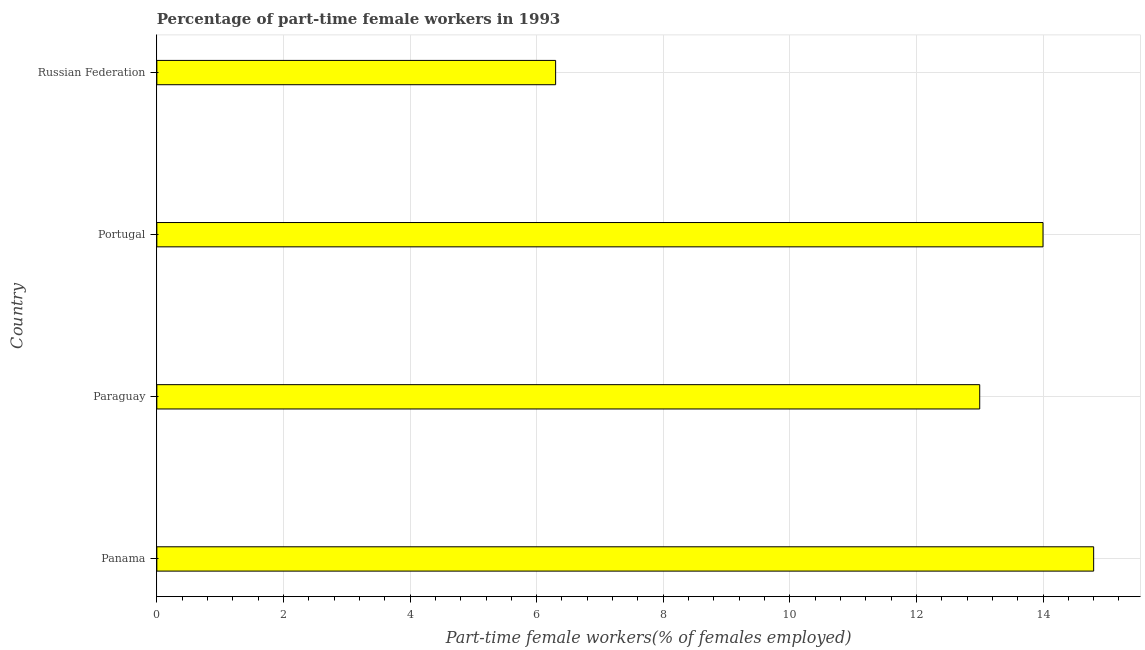Does the graph contain any zero values?
Your response must be concise. No. What is the title of the graph?
Offer a terse response. Percentage of part-time female workers in 1993. What is the label or title of the X-axis?
Offer a terse response. Part-time female workers(% of females employed). What is the label or title of the Y-axis?
Your answer should be compact. Country. Across all countries, what is the maximum percentage of part-time female workers?
Your answer should be compact. 14.8. Across all countries, what is the minimum percentage of part-time female workers?
Your answer should be very brief. 6.3. In which country was the percentage of part-time female workers maximum?
Offer a terse response. Panama. In which country was the percentage of part-time female workers minimum?
Make the answer very short. Russian Federation. What is the sum of the percentage of part-time female workers?
Ensure brevity in your answer.  48.1. What is the average percentage of part-time female workers per country?
Ensure brevity in your answer.  12.03. What is the median percentage of part-time female workers?
Ensure brevity in your answer.  13.5. In how many countries, is the percentage of part-time female workers greater than 7.6 %?
Provide a short and direct response. 3. What is the ratio of the percentage of part-time female workers in Paraguay to that in Russian Federation?
Your answer should be compact. 2.06. Is the difference between the percentage of part-time female workers in Paraguay and Russian Federation greater than the difference between any two countries?
Provide a short and direct response. No. What is the difference between the highest and the second highest percentage of part-time female workers?
Make the answer very short. 0.8. Is the sum of the percentage of part-time female workers in Panama and Portugal greater than the maximum percentage of part-time female workers across all countries?
Keep it short and to the point. Yes. What is the difference between the highest and the lowest percentage of part-time female workers?
Your response must be concise. 8.5. In how many countries, is the percentage of part-time female workers greater than the average percentage of part-time female workers taken over all countries?
Give a very brief answer. 3. How many bars are there?
Offer a very short reply. 4. Are the values on the major ticks of X-axis written in scientific E-notation?
Make the answer very short. No. What is the Part-time female workers(% of females employed) in Panama?
Your answer should be very brief. 14.8. What is the Part-time female workers(% of females employed) of Paraguay?
Keep it short and to the point. 13. What is the Part-time female workers(% of females employed) of Portugal?
Your answer should be very brief. 14. What is the Part-time female workers(% of females employed) of Russian Federation?
Make the answer very short. 6.3. What is the difference between the Part-time female workers(% of females employed) in Panama and Paraguay?
Make the answer very short. 1.8. What is the difference between the Part-time female workers(% of females employed) in Panama and Portugal?
Give a very brief answer. 0.8. What is the difference between the Part-time female workers(% of females employed) in Panama and Russian Federation?
Provide a short and direct response. 8.5. What is the difference between the Part-time female workers(% of females employed) in Paraguay and Portugal?
Make the answer very short. -1. What is the difference between the Part-time female workers(% of females employed) in Portugal and Russian Federation?
Your answer should be compact. 7.7. What is the ratio of the Part-time female workers(% of females employed) in Panama to that in Paraguay?
Provide a short and direct response. 1.14. What is the ratio of the Part-time female workers(% of females employed) in Panama to that in Portugal?
Make the answer very short. 1.06. What is the ratio of the Part-time female workers(% of females employed) in Panama to that in Russian Federation?
Provide a short and direct response. 2.35. What is the ratio of the Part-time female workers(% of females employed) in Paraguay to that in Portugal?
Provide a short and direct response. 0.93. What is the ratio of the Part-time female workers(% of females employed) in Paraguay to that in Russian Federation?
Ensure brevity in your answer.  2.06. What is the ratio of the Part-time female workers(% of females employed) in Portugal to that in Russian Federation?
Offer a terse response. 2.22. 